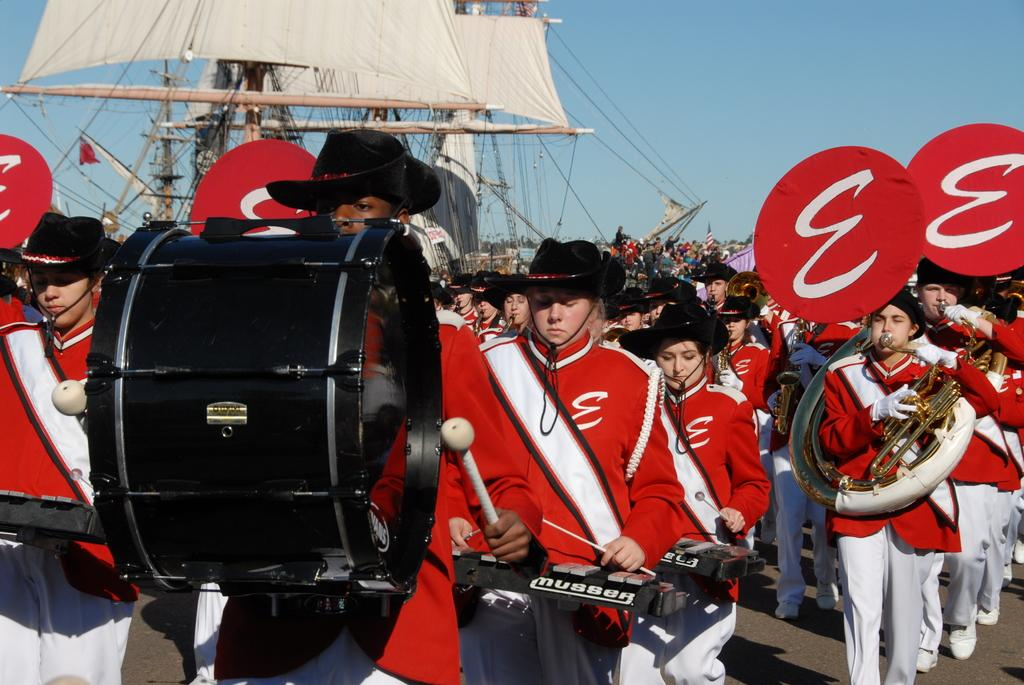How many people are in the image? The number of people in the image cannot be determined from the provided facts. What are some of the people in the image doing? Some people in the image are playing musical instruments. What structures can be seen in the image? There are poles and wires visible in the image. What type of material is visible in the image? Cloth is visible in the image. What is visible in the background of the image? The sky is visible in the image. What type of nut is being used to perform arithmetic calculations in the image? There is no nut present in the image, and no arithmetic calculations are being performed. How many drops of water can be seen falling from the sky in the image? There is no mention of rain or water drops in the image. 